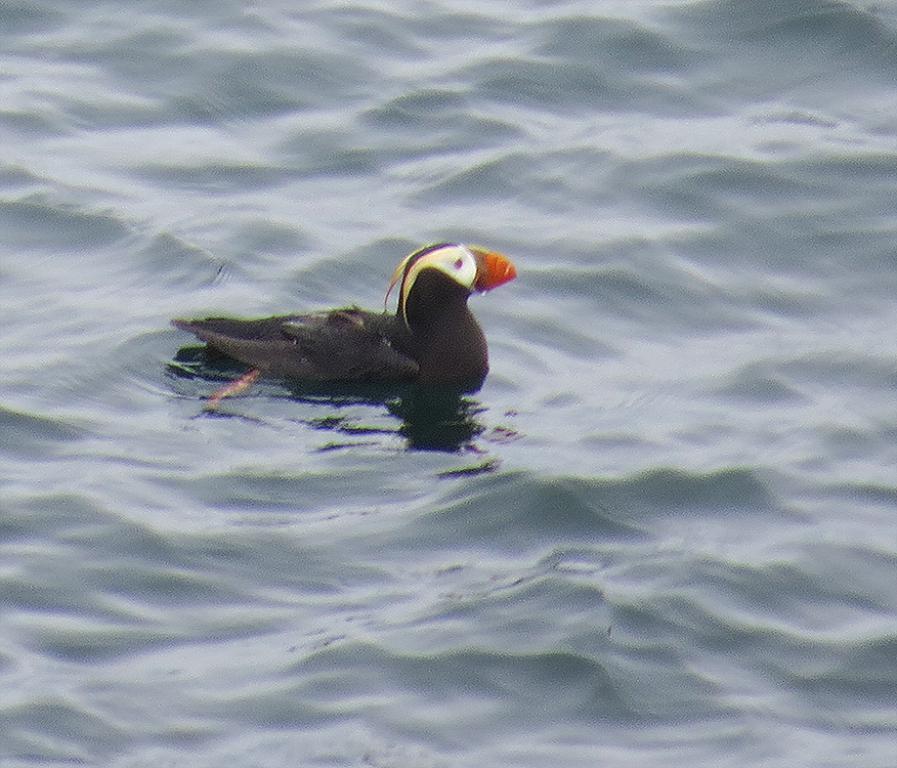Can you describe this image briefly? In this picture, we can see a sea bird in the water. 